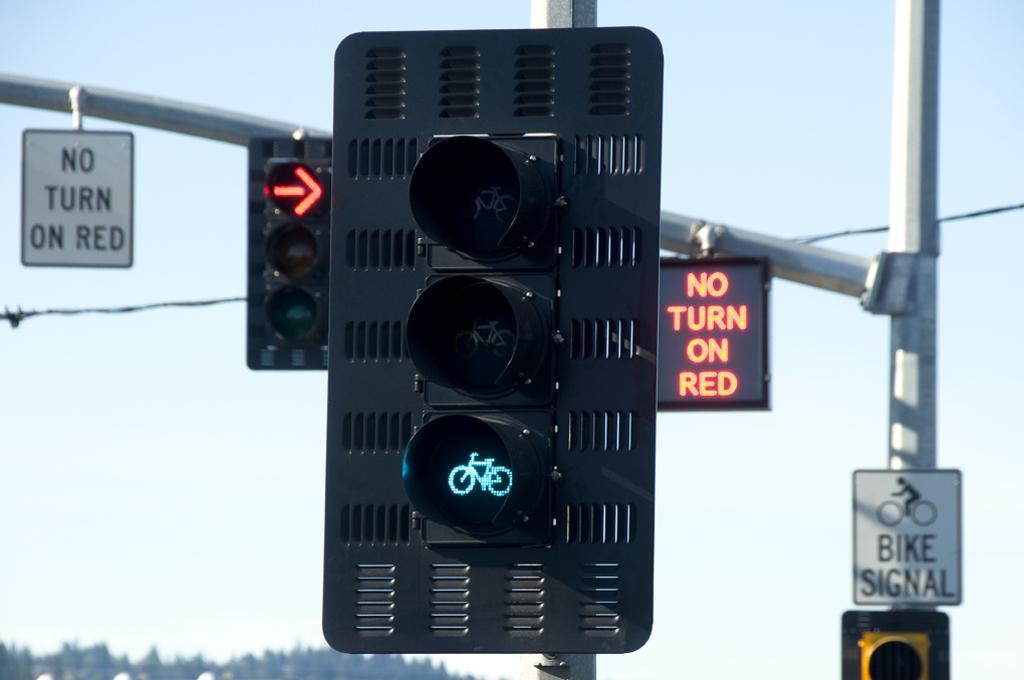Describe this image in one or two sentences. In this image there is a traffic light attached to the pole. Behind there are traffic lights and boards attached to the pole. Left bottom there are trees. Background there is sky. 